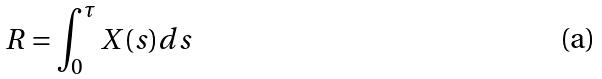<formula> <loc_0><loc_0><loc_500><loc_500>R = \int _ { 0 } ^ { \tau } X ( s ) d s</formula> 